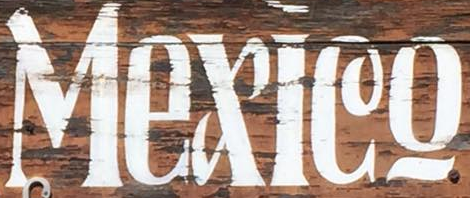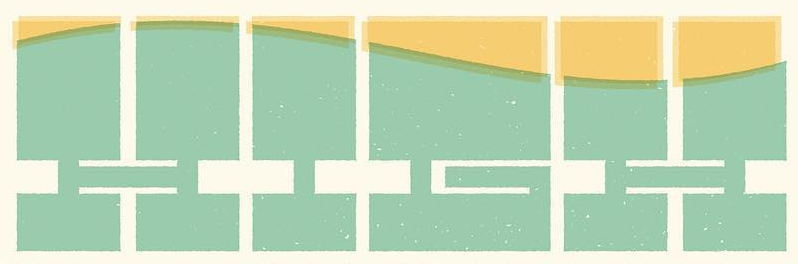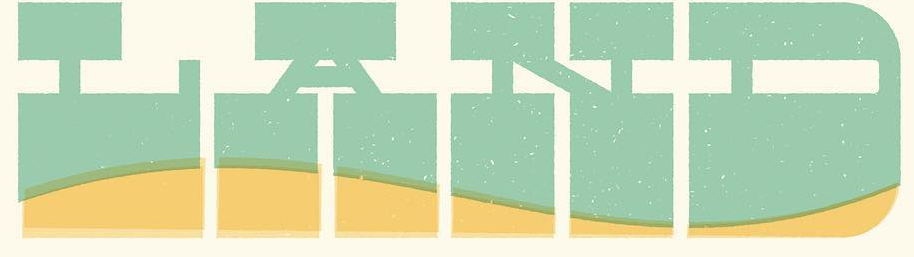What words can you see in these images in sequence, separated by a semicolon? Mexleo; HIGH; LAND 